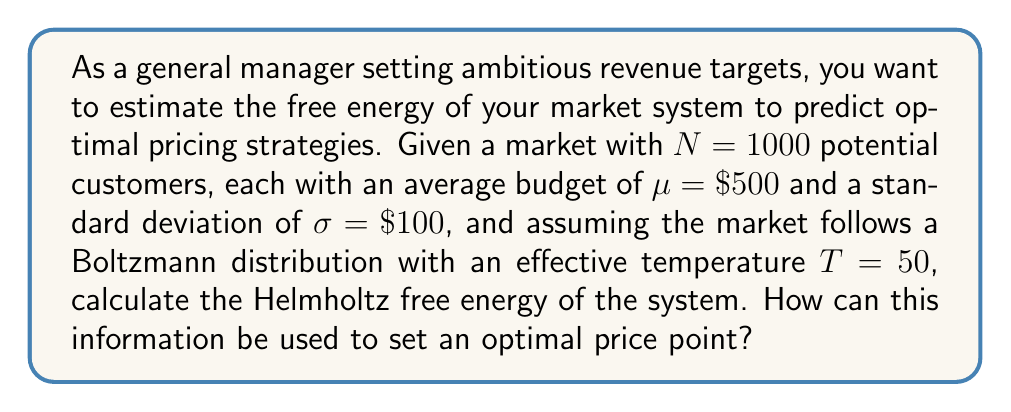Show me your answer to this math problem. To solve this problem, we'll follow these steps:

1) The Helmholtz free energy is given by the formula:

   $$F = U - TS$$

   where $F$ is the free energy, $U$ is the internal energy, $T$ is the temperature, and $S$ is the entropy.

2) In this market system, we can consider the internal energy $U$ as the total budget of all customers:

   $$U = N\mu = 1000 \cdot \$500 = \$500,000$$

3) To calculate the entropy, we'll use the formula for the entropy of a Gaussian distribution:

   $$S = \frac{1}{2}\ln(2\pi e\sigma^2)$$

   Substituting our values:

   $$S = \frac{1}{2}\ln(2\pi e \cdot (\$100)^2) \approx 5.419$$

4) Now we can calculate the total entropy of the system:

   $$S_{total} = NS = 1000 \cdot 5.419 = 5419$$

5) Finally, we can calculate the Helmholtz free energy:

   $$F = U - TS = \$500,000 - 50 \cdot 5419 = \$229,050$$

6) To use this for optimal pricing, we can interpret the free energy as the maximum amount of work (or in this case, revenue) that can be extracted from the system. The optimal price point would be one that allows us to approach this maximum while considering other market factors.

7) A starting point for the optimal price could be the average budget minus one standard deviation:

   $$P_{optimal} \approx \mu - \sigma = \$500 - \$100 = \$400$$

   This price would capture a large portion of the market while still allowing for some higher-priced offerings.
Answer: $F = \$229,050$; Optimal starting price ≈ $\$400$ 